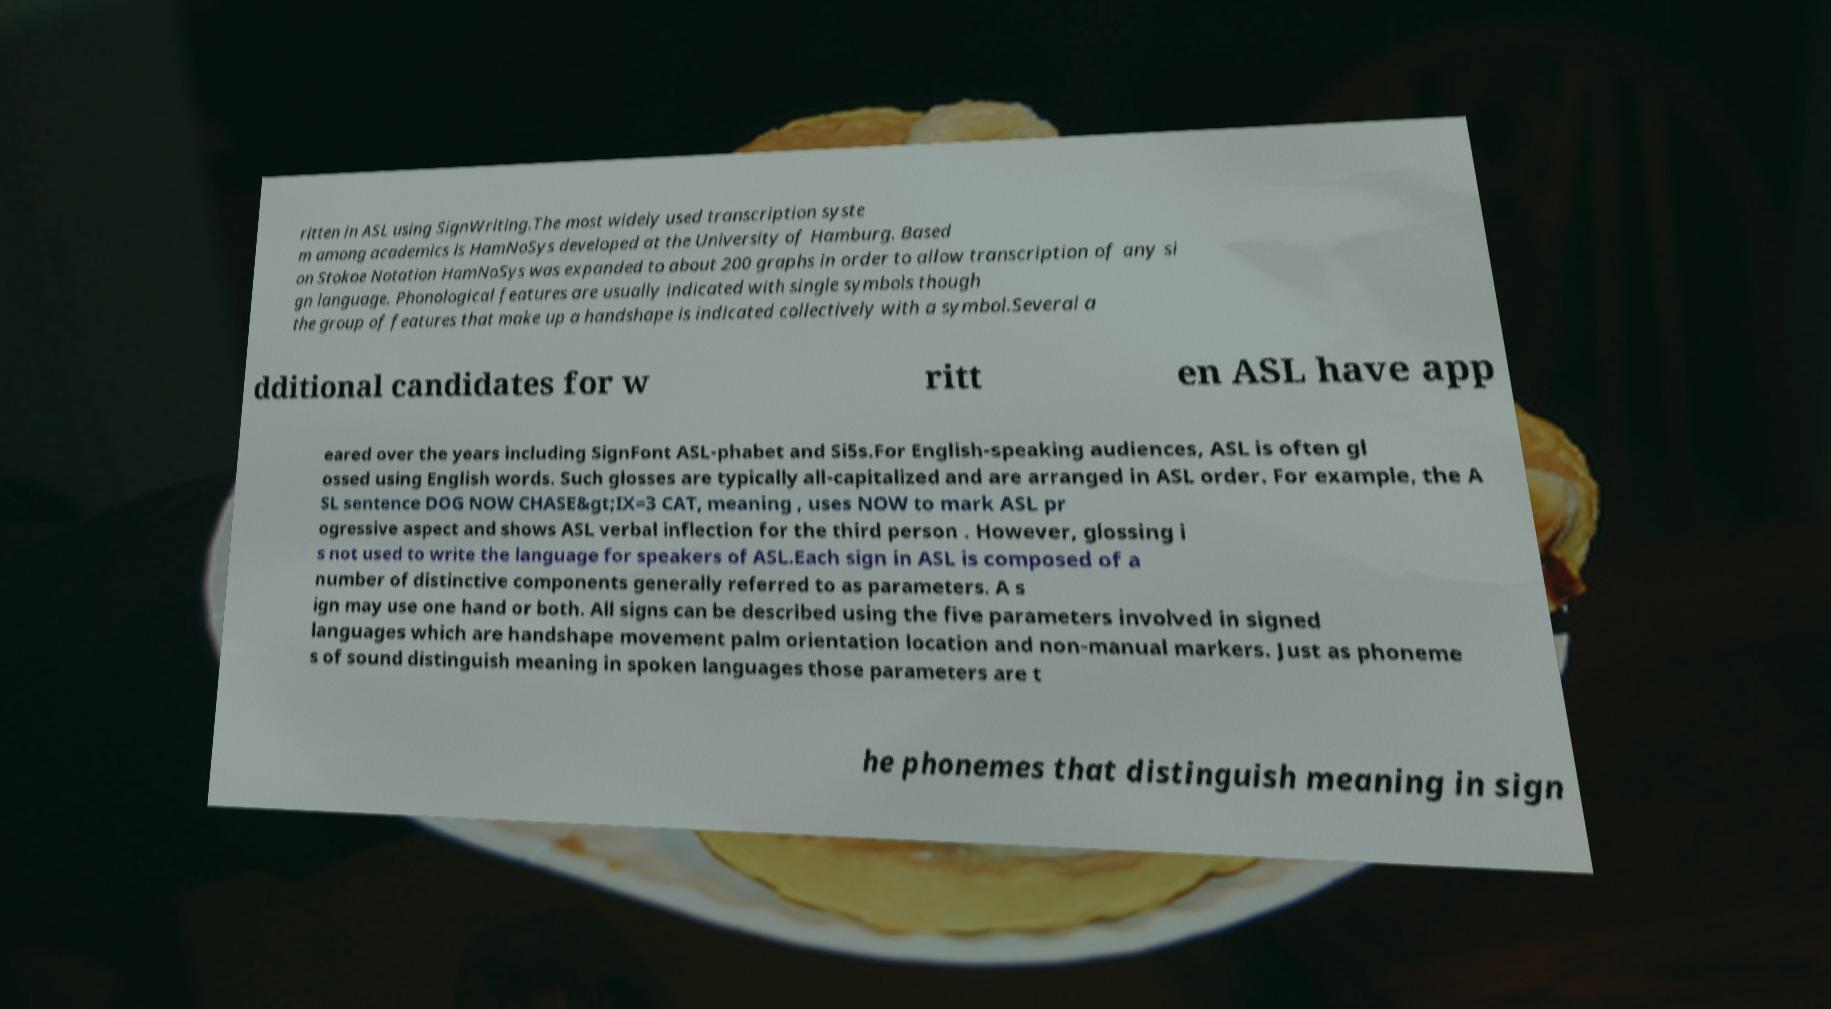Please identify and transcribe the text found in this image. ritten in ASL using SignWriting.The most widely used transcription syste m among academics is HamNoSys developed at the University of Hamburg. Based on Stokoe Notation HamNoSys was expanded to about 200 graphs in order to allow transcription of any si gn language. Phonological features are usually indicated with single symbols though the group of features that make up a handshape is indicated collectively with a symbol.Several a dditional candidates for w ritt en ASL have app eared over the years including SignFont ASL-phabet and Si5s.For English-speaking audiences, ASL is often gl ossed using English words. Such glosses are typically all-capitalized and are arranged in ASL order. For example, the A SL sentence DOG NOW CHASE&gt;IX=3 CAT, meaning , uses NOW to mark ASL pr ogressive aspect and shows ASL verbal inflection for the third person . However, glossing i s not used to write the language for speakers of ASL.Each sign in ASL is composed of a number of distinctive components generally referred to as parameters. A s ign may use one hand or both. All signs can be described using the five parameters involved in signed languages which are handshape movement palm orientation location and non-manual markers. Just as phoneme s of sound distinguish meaning in spoken languages those parameters are t he phonemes that distinguish meaning in sign 